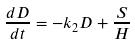<formula> <loc_0><loc_0><loc_500><loc_500>\frac { d D } { d t } = - k _ { 2 } D + \frac { S } { H }</formula> 